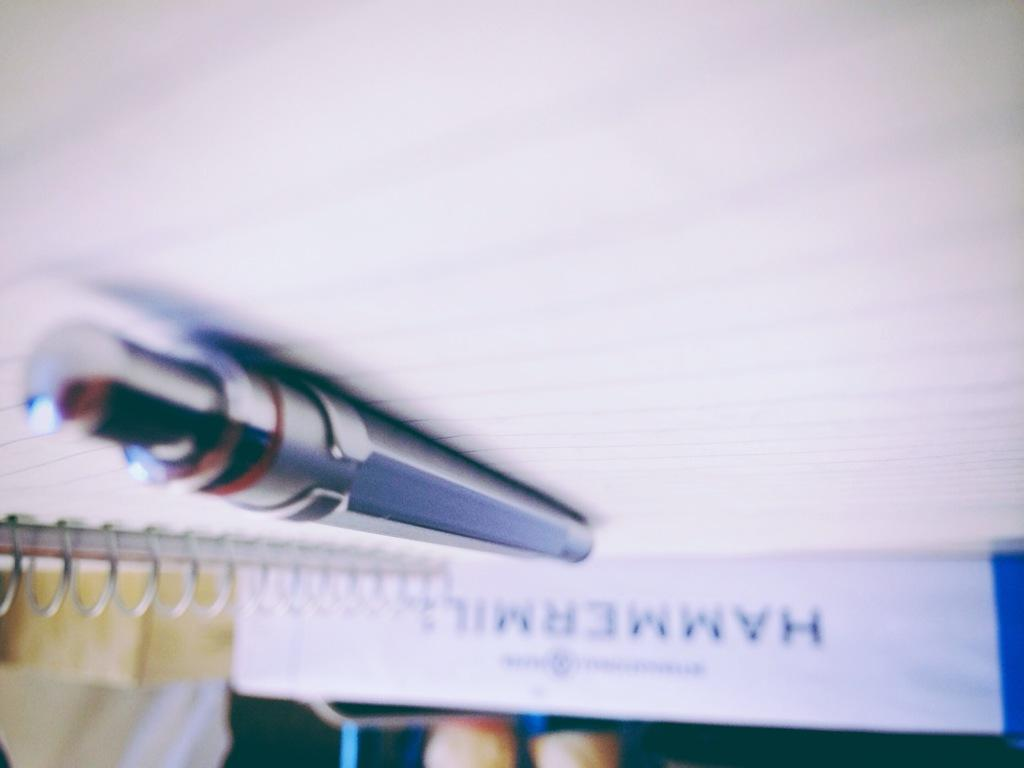What is the main object in the center of the image? There is a pen in the center of the image. What is the pen resting on? The pen is on a book. What else can be seen in the background of the image? There are other books visible in the background of the image. Can you tell me how many monkeys are sitting on the eggnog in the image? There are no monkeys or eggnog present in the image; it only features a pen on a book and other books in the background. 